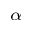Convert formula to latex. <formula><loc_0><loc_0><loc_500><loc_500>_ { \alpha }</formula> 